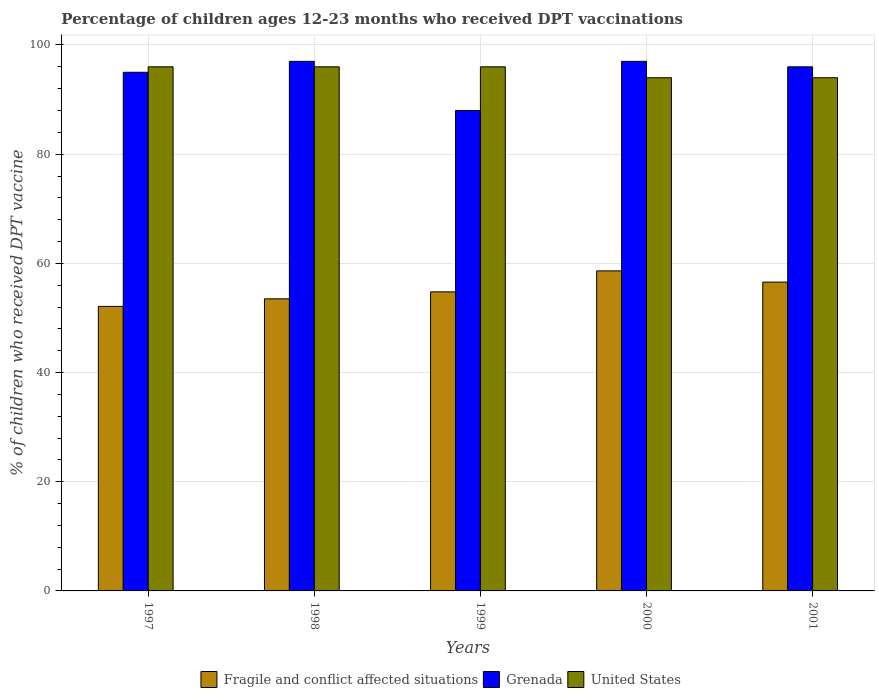How many different coloured bars are there?
Your answer should be compact. 3. How many groups of bars are there?
Provide a short and direct response. 5. Are the number of bars on each tick of the X-axis equal?
Provide a short and direct response. Yes. How many bars are there on the 1st tick from the left?
Offer a terse response. 3. What is the label of the 2nd group of bars from the left?
Make the answer very short. 1998. What is the percentage of children who received DPT vaccination in United States in 1999?
Your answer should be compact. 96. Across all years, what is the maximum percentage of children who received DPT vaccination in Fragile and conflict affected situations?
Offer a very short reply. 58.62. Across all years, what is the minimum percentage of children who received DPT vaccination in Grenada?
Your response must be concise. 88. In which year was the percentage of children who received DPT vaccination in United States minimum?
Your response must be concise. 2000. What is the total percentage of children who received DPT vaccination in Fragile and conflict affected situations in the graph?
Provide a succinct answer. 275.59. What is the difference between the percentage of children who received DPT vaccination in Fragile and conflict affected situations in 1997 and that in 1999?
Offer a terse response. -2.67. What is the difference between the percentage of children who received DPT vaccination in United States in 2000 and the percentage of children who received DPT vaccination in Fragile and conflict affected situations in 1999?
Provide a succinct answer. 39.22. What is the average percentage of children who received DPT vaccination in Grenada per year?
Offer a terse response. 94.6. In the year 1997, what is the difference between the percentage of children who received DPT vaccination in Grenada and percentage of children who received DPT vaccination in Fragile and conflict affected situations?
Your response must be concise. 42.88. What is the ratio of the percentage of children who received DPT vaccination in Fragile and conflict affected situations in 1997 to that in 1998?
Offer a very short reply. 0.97. What is the difference between the highest and the second highest percentage of children who received DPT vaccination in United States?
Give a very brief answer. 0. What is the difference between the highest and the lowest percentage of children who received DPT vaccination in Fragile and conflict affected situations?
Keep it short and to the point. 6.5. In how many years, is the percentage of children who received DPT vaccination in Fragile and conflict affected situations greater than the average percentage of children who received DPT vaccination in Fragile and conflict affected situations taken over all years?
Keep it short and to the point. 2. What does the 1st bar from the left in 1998 represents?
Make the answer very short. Fragile and conflict affected situations. What does the 2nd bar from the right in 1999 represents?
Provide a short and direct response. Grenada. Is it the case that in every year, the sum of the percentage of children who received DPT vaccination in United States and percentage of children who received DPT vaccination in Fragile and conflict affected situations is greater than the percentage of children who received DPT vaccination in Grenada?
Provide a short and direct response. Yes. Are all the bars in the graph horizontal?
Make the answer very short. No. Does the graph contain grids?
Ensure brevity in your answer.  Yes. How are the legend labels stacked?
Offer a terse response. Horizontal. What is the title of the graph?
Offer a terse response. Percentage of children ages 12-23 months who received DPT vaccinations. Does "OECD members" appear as one of the legend labels in the graph?
Offer a very short reply. No. What is the label or title of the X-axis?
Provide a short and direct response. Years. What is the label or title of the Y-axis?
Your response must be concise. % of children who received DPT vaccine. What is the % of children who received DPT vaccine of Fragile and conflict affected situations in 1997?
Give a very brief answer. 52.12. What is the % of children who received DPT vaccine of United States in 1997?
Make the answer very short. 96. What is the % of children who received DPT vaccine of Fragile and conflict affected situations in 1998?
Offer a terse response. 53.5. What is the % of children who received DPT vaccine in Grenada in 1998?
Your answer should be very brief. 97. What is the % of children who received DPT vaccine in United States in 1998?
Your answer should be very brief. 96. What is the % of children who received DPT vaccine in Fragile and conflict affected situations in 1999?
Keep it short and to the point. 54.78. What is the % of children who received DPT vaccine of Grenada in 1999?
Offer a terse response. 88. What is the % of children who received DPT vaccine of United States in 1999?
Offer a very short reply. 96. What is the % of children who received DPT vaccine in Fragile and conflict affected situations in 2000?
Provide a short and direct response. 58.62. What is the % of children who received DPT vaccine in Grenada in 2000?
Provide a succinct answer. 97. What is the % of children who received DPT vaccine of United States in 2000?
Your response must be concise. 94. What is the % of children who received DPT vaccine of Fragile and conflict affected situations in 2001?
Your answer should be compact. 56.57. What is the % of children who received DPT vaccine in Grenada in 2001?
Your answer should be compact. 96. What is the % of children who received DPT vaccine of United States in 2001?
Provide a short and direct response. 94. Across all years, what is the maximum % of children who received DPT vaccine in Fragile and conflict affected situations?
Your response must be concise. 58.62. Across all years, what is the maximum % of children who received DPT vaccine in Grenada?
Provide a short and direct response. 97. Across all years, what is the maximum % of children who received DPT vaccine of United States?
Ensure brevity in your answer.  96. Across all years, what is the minimum % of children who received DPT vaccine of Fragile and conflict affected situations?
Offer a very short reply. 52.12. Across all years, what is the minimum % of children who received DPT vaccine in United States?
Your answer should be compact. 94. What is the total % of children who received DPT vaccine in Fragile and conflict affected situations in the graph?
Offer a very short reply. 275.59. What is the total % of children who received DPT vaccine of Grenada in the graph?
Your answer should be compact. 473. What is the total % of children who received DPT vaccine in United States in the graph?
Provide a short and direct response. 476. What is the difference between the % of children who received DPT vaccine in Fragile and conflict affected situations in 1997 and that in 1998?
Offer a terse response. -1.39. What is the difference between the % of children who received DPT vaccine of United States in 1997 and that in 1998?
Offer a terse response. 0. What is the difference between the % of children who received DPT vaccine in Fragile and conflict affected situations in 1997 and that in 1999?
Ensure brevity in your answer.  -2.67. What is the difference between the % of children who received DPT vaccine in Grenada in 1997 and that in 1999?
Your answer should be compact. 7. What is the difference between the % of children who received DPT vaccine of United States in 1997 and that in 1999?
Provide a succinct answer. 0. What is the difference between the % of children who received DPT vaccine in Fragile and conflict affected situations in 1997 and that in 2000?
Provide a short and direct response. -6.5. What is the difference between the % of children who received DPT vaccine in United States in 1997 and that in 2000?
Keep it short and to the point. 2. What is the difference between the % of children who received DPT vaccine in Fragile and conflict affected situations in 1997 and that in 2001?
Provide a short and direct response. -4.45. What is the difference between the % of children who received DPT vaccine of United States in 1997 and that in 2001?
Offer a terse response. 2. What is the difference between the % of children who received DPT vaccine of Fragile and conflict affected situations in 1998 and that in 1999?
Give a very brief answer. -1.28. What is the difference between the % of children who received DPT vaccine of Fragile and conflict affected situations in 1998 and that in 2000?
Make the answer very short. -5.12. What is the difference between the % of children who received DPT vaccine of United States in 1998 and that in 2000?
Offer a terse response. 2. What is the difference between the % of children who received DPT vaccine of Fragile and conflict affected situations in 1998 and that in 2001?
Keep it short and to the point. -3.06. What is the difference between the % of children who received DPT vaccine in Grenada in 1998 and that in 2001?
Your answer should be compact. 1. What is the difference between the % of children who received DPT vaccine in United States in 1998 and that in 2001?
Make the answer very short. 2. What is the difference between the % of children who received DPT vaccine of Fragile and conflict affected situations in 1999 and that in 2000?
Provide a succinct answer. -3.84. What is the difference between the % of children who received DPT vaccine of Grenada in 1999 and that in 2000?
Your response must be concise. -9. What is the difference between the % of children who received DPT vaccine in United States in 1999 and that in 2000?
Offer a terse response. 2. What is the difference between the % of children who received DPT vaccine in Fragile and conflict affected situations in 1999 and that in 2001?
Provide a short and direct response. -1.78. What is the difference between the % of children who received DPT vaccine in Grenada in 1999 and that in 2001?
Give a very brief answer. -8. What is the difference between the % of children who received DPT vaccine of Fragile and conflict affected situations in 2000 and that in 2001?
Your answer should be compact. 2.05. What is the difference between the % of children who received DPT vaccine in Grenada in 2000 and that in 2001?
Make the answer very short. 1. What is the difference between the % of children who received DPT vaccine of United States in 2000 and that in 2001?
Ensure brevity in your answer.  0. What is the difference between the % of children who received DPT vaccine in Fragile and conflict affected situations in 1997 and the % of children who received DPT vaccine in Grenada in 1998?
Your response must be concise. -44.88. What is the difference between the % of children who received DPT vaccine of Fragile and conflict affected situations in 1997 and the % of children who received DPT vaccine of United States in 1998?
Your answer should be compact. -43.88. What is the difference between the % of children who received DPT vaccine in Fragile and conflict affected situations in 1997 and the % of children who received DPT vaccine in Grenada in 1999?
Offer a very short reply. -35.88. What is the difference between the % of children who received DPT vaccine in Fragile and conflict affected situations in 1997 and the % of children who received DPT vaccine in United States in 1999?
Offer a very short reply. -43.88. What is the difference between the % of children who received DPT vaccine in Fragile and conflict affected situations in 1997 and the % of children who received DPT vaccine in Grenada in 2000?
Your response must be concise. -44.88. What is the difference between the % of children who received DPT vaccine in Fragile and conflict affected situations in 1997 and the % of children who received DPT vaccine in United States in 2000?
Your answer should be compact. -41.88. What is the difference between the % of children who received DPT vaccine in Fragile and conflict affected situations in 1997 and the % of children who received DPT vaccine in Grenada in 2001?
Keep it short and to the point. -43.88. What is the difference between the % of children who received DPT vaccine of Fragile and conflict affected situations in 1997 and the % of children who received DPT vaccine of United States in 2001?
Keep it short and to the point. -41.88. What is the difference between the % of children who received DPT vaccine of Grenada in 1997 and the % of children who received DPT vaccine of United States in 2001?
Give a very brief answer. 1. What is the difference between the % of children who received DPT vaccine of Fragile and conflict affected situations in 1998 and the % of children who received DPT vaccine of Grenada in 1999?
Your response must be concise. -34.5. What is the difference between the % of children who received DPT vaccine of Fragile and conflict affected situations in 1998 and the % of children who received DPT vaccine of United States in 1999?
Ensure brevity in your answer.  -42.5. What is the difference between the % of children who received DPT vaccine of Grenada in 1998 and the % of children who received DPT vaccine of United States in 1999?
Your answer should be very brief. 1. What is the difference between the % of children who received DPT vaccine of Fragile and conflict affected situations in 1998 and the % of children who received DPT vaccine of Grenada in 2000?
Your response must be concise. -43.5. What is the difference between the % of children who received DPT vaccine of Fragile and conflict affected situations in 1998 and the % of children who received DPT vaccine of United States in 2000?
Offer a terse response. -40.5. What is the difference between the % of children who received DPT vaccine of Fragile and conflict affected situations in 1998 and the % of children who received DPT vaccine of Grenada in 2001?
Keep it short and to the point. -42.5. What is the difference between the % of children who received DPT vaccine of Fragile and conflict affected situations in 1998 and the % of children who received DPT vaccine of United States in 2001?
Give a very brief answer. -40.5. What is the difference between the % of children who received DPT vaccine of Grenada in 1998 and the % of children who received DPT vaccine of United States in 2001?
Give a very brief answer. 3. What is the difference between the % of children who received DPT vaccine in Fragile and conflict affected situations in 1999 and the % of children who received DPT vaccine in Grenada in 2000?
Your response must be concise. -42.22. What is the difference between the % of children who received DPT vaccine in Fragile and conflict affected situations in 1999 and the % of children who received DPT vaccine in United States in 2000?
Your response must be concise. -39.22. What is the difference between the % of children who received DPT vaccine of Grenada in 1999 and the % of children who received DPT vaccine of United States in 2000?
Provide a short and direct response. -6. What is the difference between the % of children who received DPT vaccine in Fragile and conflict affected situations in 1999 and the % of children who received DPT vaccine in Grenada in 2001?
Offer a very short reply. -41.22. What is the difference between the % of children who received DPT vaccine in Fragile and conflict affected situations in 1999 and the % of children who received DPT vaccine in United States in 2001?
Your response must be concise. -39.22. What is the difference between the % of children who received DPT vaccine of Grenada in 1999 and the % of children who received DPT vaccine of United States in 2001?
Make the answer very short. -6. What is the difference between the % of children who received DPT vaccine in Fragile and conflict affected situations in 2000 and the % of children who received DPT vaccine in Grenada in 2001?
Your answer should be compact. -37.38. What is the difference between the % of children who received DPT vaccine of Fragile and conflict affected situations in 2000 and the % of children who received DPT vaccine of United States in 2001?
Offer a very short reply. -35.38. What is the average % of children who received DPT vaccine in Fragile and conflict affected situations per year?
Give a very brief answer. 55.12. What is the average % of children who received DPT vaccine of Grenada per year?
Keep it short and to the point. 94.6. What is the average % of children who received DPT vaccine of United States per year?
Give a very brief answer. 95.2. In the year 1997, what is the difference between the % of children who received DPT vaccine of Fragile and conflict affected situations and % of children who received DPT vaccine of Grenada?
Your answer should be very brief. -42.88. In the year 1997, what is the difference between the % of children who received DPT vaccine in Fragile and conflict affected situations and % of children who received DPT vaccine in United States?
Provide a succinct answer. -43.88. In the year 1998, what is the difference between the % of children who received DPT vaccine of Fragile and conflict affected situations and % of children who received DPT vaccine of Grenada?
Your answer should be very brief. -43.5. In the year 1998, what is the difference between the % of children who received DPT vaccine of Fragile and conflict affected situations and % of children who received DPT vaccine of United States?
Offer a very short reply. -42.5. In the year 1999, what is the difference between the % of children who received DPT vaccine of Fragile and conflict affected situations and % of children who received DPT vaccine of Grenada?
Offer a terse response. -33.22. In the year 1999, what is the difference between the % of children who received DPT vaccine of Fragile and conflict affected situations and % of children who received DPT vaccine of United States?
Your answer should be compact. -41.22. In the year 2000, what is the difference between the % of children who received DPT vaccine of Fragile and conflict affected situations and % of children who received DPT vaccine of Grenada?
Offer a very short reply. -38.38. In the year 2000, what is the difference between the % of children who received DPT vaccine of Fragile and conflict affected situations and % of children who received DPT vaccine of United States?
Keep it short and to the point. -35.38. In the year 2000, what is the difference between the % of children who received DPT vaccine in Grenada and % of children who received DPT vaccine in United States?
Make the answer very short. 3. In the year 2001, what is the difference between the % of children who received DPT vaccine of Fragile and conflict affected situations and % of children who received DPT vaccine of Grenada?
Offer a very short reply. -39.43. In the year 2001, what is the difference between the % of children who received DPT vaccine of Fragile and conflict affected situations and % of children who received DPT vaccine of United States?
Make the answer very short. -37.43. In the year 2001, what is the difference between the % of children who received DPT vaccine in Grenada and % of children who received DPT vaccine in United States?
Provide a succinct answer. 2. What is the ratio of the % of children who received DPT vaccine in Fragile and conflict affected situations in 1997 to that in 1998?
Ensure brevity in your answer.  0.97. What is the ratio of the % of children who received DPT vaccine in Grenada in 1997 to that in 1998?
Provide a succinct answer. 0.98. What is the ratio of the % of children who received DPT vaccine of United States in 1997 to that in 1998?
Give a very brief answer. 1. What is the ratio of the % of children who received DPT vaccine in Fragile and conflict affected situations in 1997 to that in 1999?
Your answer should be very brief. 0.95. What is the ratio of the % of children who received DPT vaccine in Grenada in 1997 to that in 1999?
Offer a terse response. 1.08. What is the ratio of the % of children who received DPT vaccine of United States in 1997 to that in 1999?
Offer a very short reply. 1. What is the ratio of the % of children who received DPT vaccine of Fragile and conflict affected situations in 1997 to that in 2000?
Provide a short and direct response. 0.89. What is the ratio of the % of children who received DPT vaccine in Grenada in 1997 to that in 2000?
Offer a terse response. 0.98. What is the ratio of the % of children who received DPT vaccine of United States in 1997 to that in 2000?
Your response must be concise. 1.02. What is the ratio of the % of children who received DPT vaccine of Fragile and conflict affected situations in 1997 to that in 2001?
Your answer should be very brief. 0.92. What is the ratio of the % of children who received DPT vaccine in Grenada in 1997 to that in 2001?
Provide a succinct answer. 0.99. What is the ratio of the % of children who received DPT vaccine in United States in 1997 to that in 2001?
Offer a terse response. 1.02. What is the ratio of the % of children who received DPT vaccine in Fragile and conflict affected situations in 1998 to that in 1999?
Make the answer very short. 0.98. What is the ratio of the % of children who received DPT vaccine of Grenada in 1998 to that in 1999?
Offer a very short reply. 1.1. What is the ratio of the % of children who received DPT vaccine in United States in 1998 to that in 1999?
Your answer should be compact. 1. What is the ratio of the % of children who received DPT vaccine of Fragile and conflict affected situations in 1998 to that in 2000?
Provide a short and direct response. 0.91. What is the ratio of the % of children who received DPT vaccine in United States in 1998 to that in 2000?
Provide a short and direct response. 1.02. What is the ratio of the % of children who received DPT vaccine of Fragile and conflict affected situations in 1998 to that in 2001?
Provide a short and direct response. 0.95. What is the ratio of the % of children who received DPT vaccine of Grenada in 1998 to that in 2001?
Your answer should be compact. 1.01. What is the ratio of the % of children who received DPT vaccine of United States in 1998 to that in 2001?
Give a very brief answer. 1.02. What is the ratio of the % of children who received DPT vaccine of Fragile and conflict affected situations in 1999 to that in 2000?
Keep it short and to the point. 0.93. What is the ratio of the % of children who received DPT vaccine in Grenada in 1999 to that in 2000?
Provide a succinct answer. 0.91. What is the ratio of the % of children who received DPT vaccine in United States in 1999 to that in 2000?
Your response must be concise. 1.02. What is the ratio of the % of children who received DPT vaccine in Fragile and conflict affected situations in 1999 to that in 2001?
Your response must be concise. 0.97. What is the ratio of the % of children who received DPT vaccine of United States in 1999 to that in 2001?
Offer a terse response. 1.02. What is the ratio of the % of children who received DPT vaccine in Fragile and conflict affected situations in 2000 to that in 2001?
Your answer should be compact. 1.04. What is the ratio of the % of children who received DPT vaccine of Grenada in 2000 to that in 2001?
Offer a very short reply. 1.01. What is the ratio of the % of children who received DPT vaccine in United States in 2000 to that in 2001?
Make the answer very short. 1. What is the difference between the highest and the second highest % of children who received DPT vaccine of Fragile and conflict affected situations?
Your answer should be compact. 2.05. What is the difference between the highest and the second highest % of children who received DPT vaccine of Grenada?
Your response must be concise. 0. What is the difference between the highest and the lowest % of children who received DPT vaccine in Fragile and conflict affected situations?
Keep it short and to the point. 6.5. What is the difference between the highest and the lowest % of children who received DPT vaccine of United States?
Your answer should be compact. 2. 